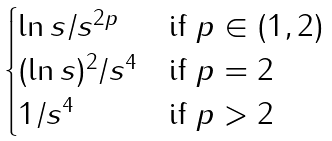<formula> <loc_0><loc_0><loc_500><loc_500>\begin{cases} \ln s / s ^ { 2 p } & \text {if $p\in (1,2)$} \\ ( \ln s ) ^ { 2 } / s ^ { 4 } & \text {if $p=2$} \\ 1 / s ^ { 4 } & \text {if $p>2$} \end{cases}</formula> 